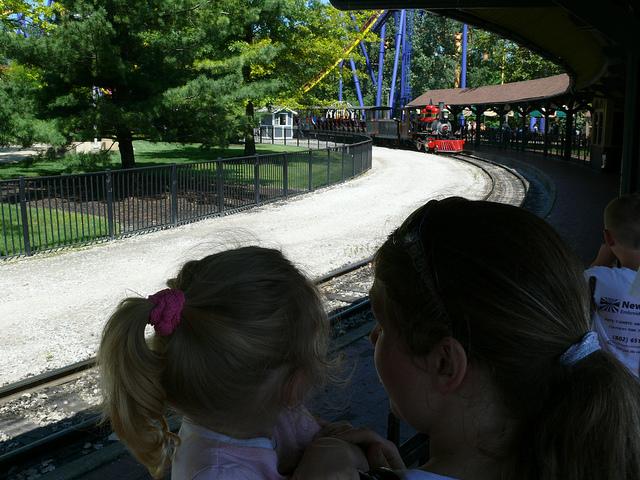Where are they at?
Concise answer only. Amusement park. What is the hairstyle of the woman and child called?
Be succinct. Ponytail. Is this outdoors?
Short answer required. Yes. Is the boy on the right sitting or standing?
Be succinct. Standing. 